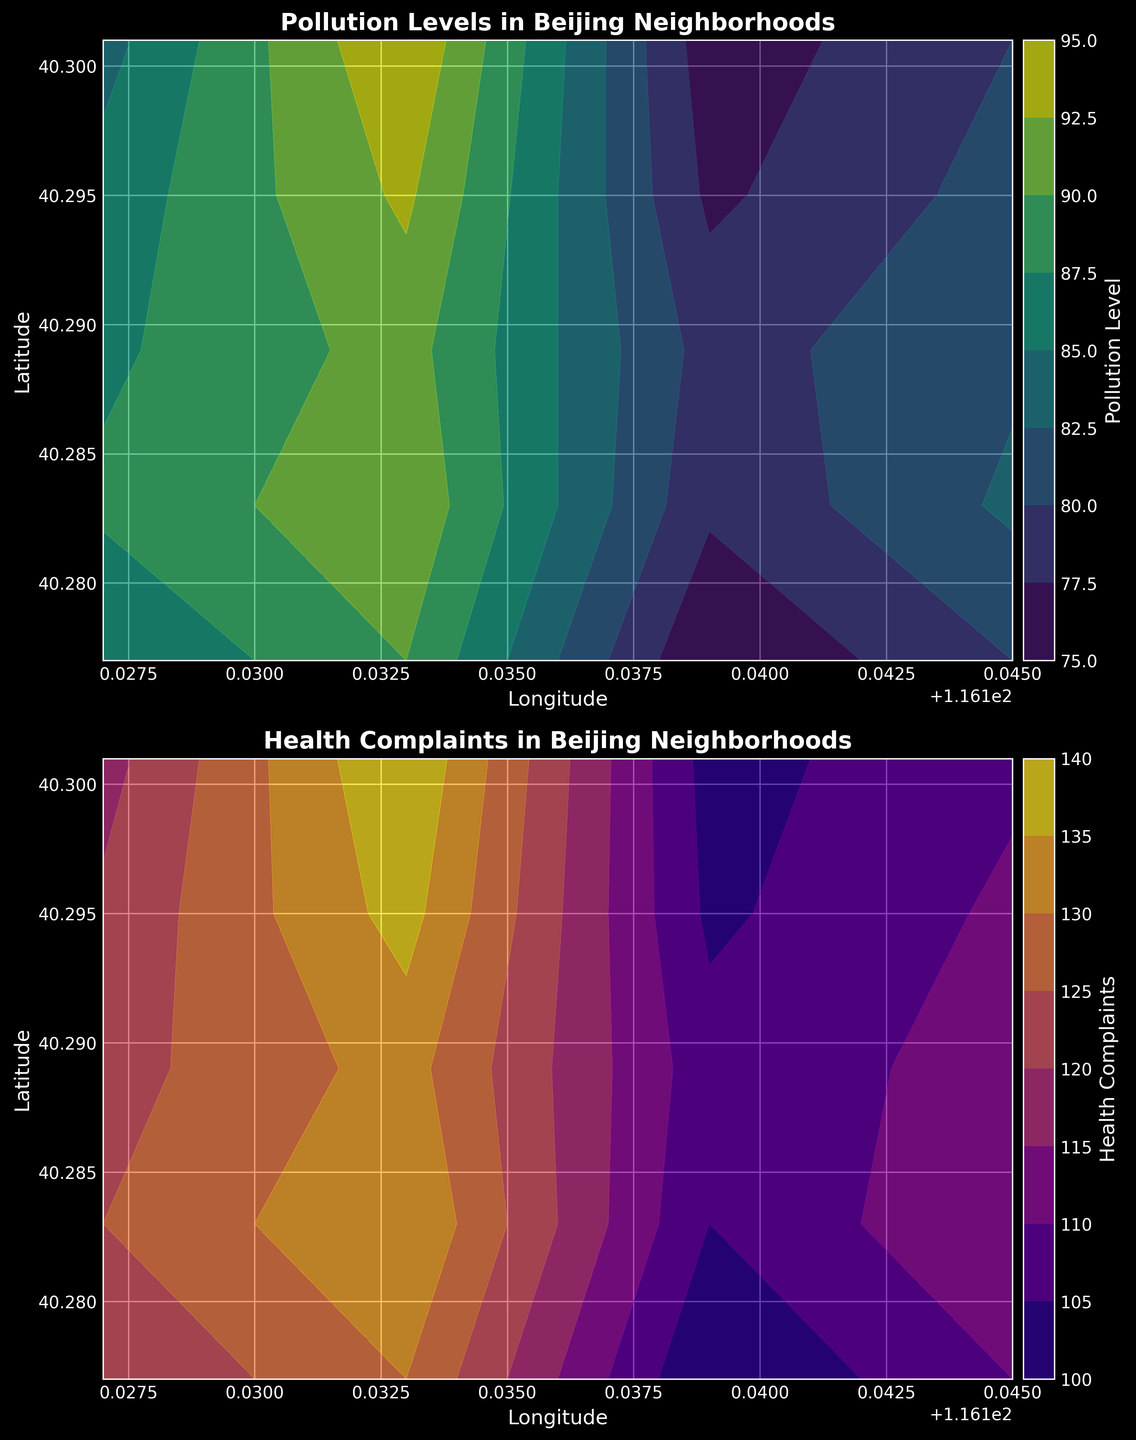What's the highest pollution level recorded in the neighborhoods? By examining the contour plot of pollution levels, we observe the color gradient corresponding to the pollution levels. The highest pollution level is identified by the darkest shade on the viridis colormap. The highest value recorded is near 116.133 longitude and 40.301 latitude.
Answer: 95 Which neighborhood shows the highest health complaints? We look at the second contour plot for the health complaints and identify the area with the most intense color on the plasma colormap. The highest value is around 116.133 longitude and 40.301 latitude, matching the highest measured value.
Answer: 140 Are there areas with similar pollution levels? To determine areas with similar pollution levels, we look for similar color shades within the contour plot of pollution levels. Multiple neighborhoods show pollution levels in the range of 80-90, indicating similar pollution levels in these areas.
Answer: Yes What’s the relationship between pollution levels and health complaints in the northernmost neighborhood? In the northernmost neighborhood, at 40.301 latitude, we compare the pollution levels and health complaints. The northernmost point shows high values for both parameters, suggesting a possible correlation. At this point, we see a pollution level of 95 and a health complaint value of 140.
Answer: Both are high Which neighborhood has the lowest pollution level? We identify the area with the lightest shade on the contour plot of pollution levels. The lightest area corresponds to the lowest pollution level. It is located near 116.139 longitude and 40.301 latitude.
Answer: 76 Is there a trend of increasing health complaints with decreasing latitude? By examining the color gradients horizontally across the latitudes in the health complaints contour plot, we observe if the colors intensify or diminish. The trend reveals that health complaints tend to remain high across varying latitudes with slight variations, so no consistent trend is observed.
Answer: No Do the regions with high pollution levels consistently show high health complaints? We compare the regions with darkest shades in the pollution levels plot with the corresponding regions in the health complaints plot. There’s a strong overlap indicating regions with high pollution levels often have high health complaints, evidencing a consistent pattern.
Answer: Yes What’s the gradient of pollution levels across the neighborhoods from west to east? Observing the gradient of colors from the westernmost (116.127 longitude) to the easternmost (116.145 longitude) in the pollution levels plot, we see a mixed gradient. Although pollution levels fluctuate slightly, no unidirectional gradient is identified.
Answer: Mixed gradient 